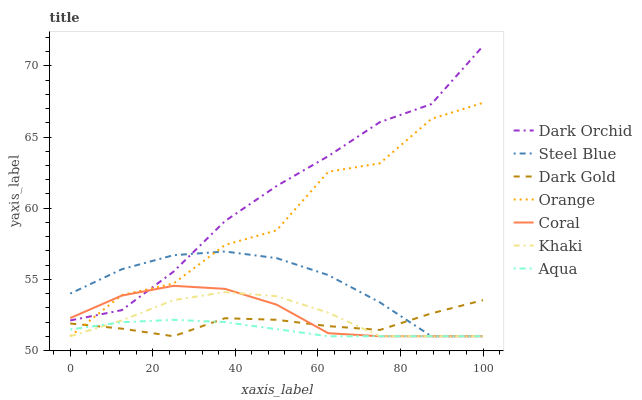Does Aqua have the minimum area under the curve?
Answer yes or no. Yes. Does Dark Orchid have the maximum area under the curve?
Answer yes or no. Yes. Does Dark Gold have the minimum area under the curve?
Answer yes or no. No. Does Dark Gold have the maximum area under the curve?
Answer yes or no. No. Is Aqua the smoothest?
Answer yes or no. Yes. Is Orange the roughest?
Answer yes or no. Yes. Is Dark Gold the smoothest?
Answer yes or no. No. Is Dark Gold the roughest?
Answer yes or no. No. Does Dark Orchid have the lowest value?
Answer yes or no. No. Does Dark Gold have the highest value?
Answer yes or no. No. Is Khaki less than Dark Orchid?
Answer yes or no. Yes. Is Dark Orchid greater than Khaki?
Answer yes or no. Yes. Does Khaki intersect Dark Orchid?
Answer yes or no. No. 